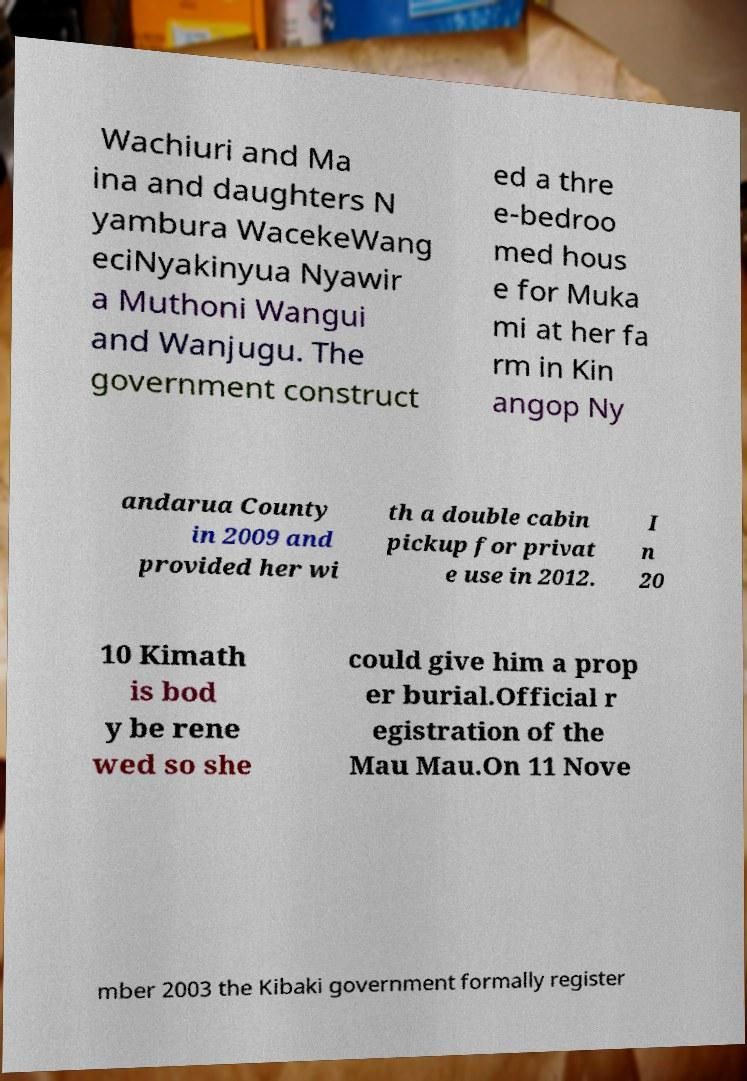Can you accurately transcribe the text from the provided image for me? Wachiuri and Ma ina and daughters N yambura WacekeWang eciNyakinyua Nyawir a Muthoni Wangui and Wanjugu. The government construct ed a thre e-bedroo med hous e for Muka mi at her fa rm in Kin angop Ny andarua County in 2009 and provided her wi th a double cabin pickup for privat e use in 2012. I n 20 10 Kimath is bod y be rene wed so she could give him a prop er burial.Official r egistration of the Mau Mau.On 11 Nove mber 2003 the Kibaki government formally register 